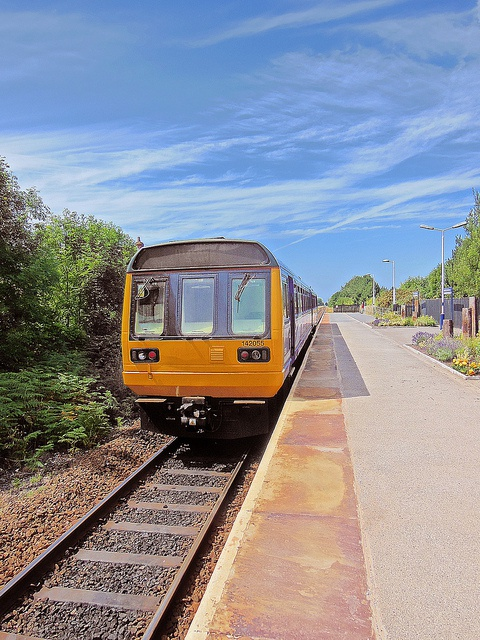Describe the objects in this image and their specific colors. I can see a train in gray, black, darkgray, and orange tones in this image. 